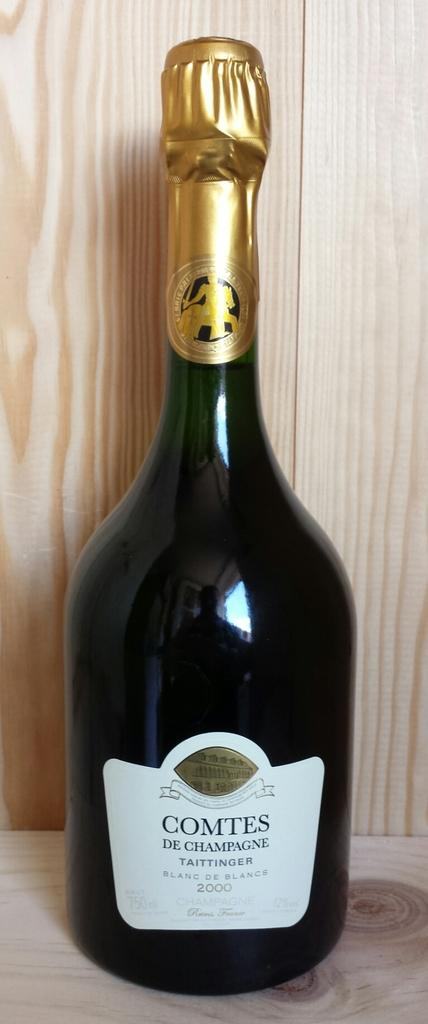<image>
Describe the image concisely. A bottle of Comtes from 2000 sits against a wooden backdrop. 